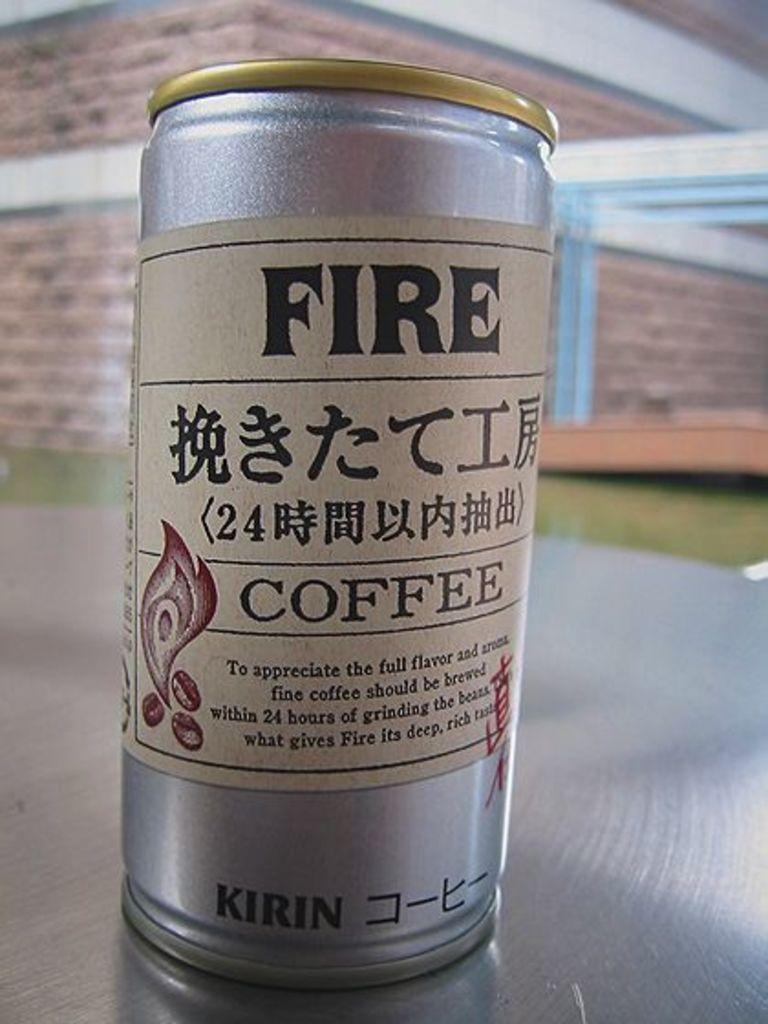What kind of coffee is that?
Provide a succinct answer. Fire. When should fine coffee be brewed to appreciate it?
Give a very brief answer. Within 24 hours of grinding the beans. 